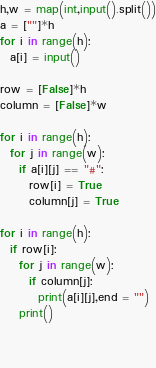Convert code to text. <code><loc_0><loc_0><loc_500><loc_500><_Python_>h,w = map(int,input().split())
a = [""]*h
for i in range(h):
  a[i] = input()

row = [False]*h
column = [False]*w

for i in range(h):
  for j in range(w):
    if a[i][j] == "#":
      row[i] = True
      column[j] = True

for i in range(h):
  if row[i]:
    for j in range(w):
      if column[j]:
        print(a[i][j],end = "")
    print()
        
    
      
</code> 